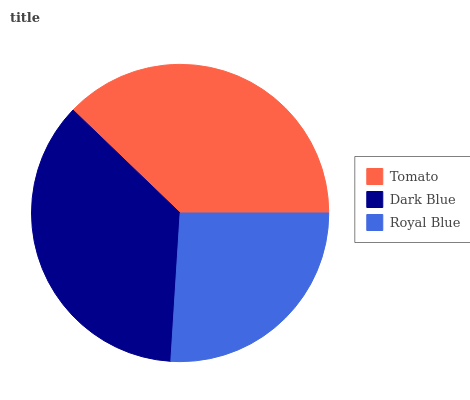Is Royal Blue the minimum?
Answer yes or no. Yes. Is Tomato the maximum?
Answer yes or no. Yes. Is Dark Blue the minimum?
Answer yes or no. No. Is Dark Blue the maximum?
Answer yes or no. No. Is Tomato greater than Dark Blue?
Answer yes or no. Yes. Is Dark Blue less than Tomato?
Answer yes or no. Yes. Is Dark Blue greater than Tomato?
Answer yes or no. No. Is Tomato less than Dark Blue?
Answer yes or no. No. Is Dark Blue the high median?
Answer yes or no. Yes. Is Dark Blue the low median?
Answer yes or no. Yes. Is Tomato the high median?
Answer yes or no. No. Is Royal Blue the low median?
Answer yes or no. No. 